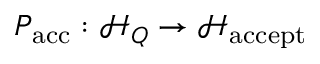<formula> <loc_0><loc_0><loc_500><loc_500>P _ { a c c } \colon { \mathcal { H } } _ { Q } \to { \mathcal { H } } _ { a c c e p t }</formula> 